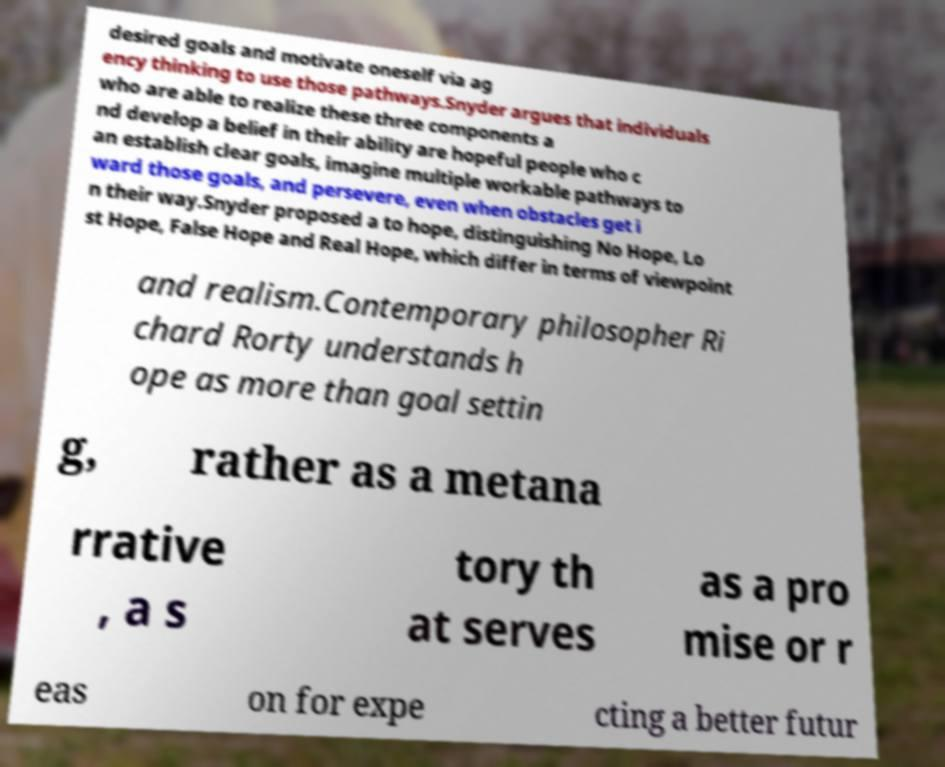Can you read and provide the text displayed in the image?This photo seems to have some interesting text. Can you extract and type it out for me? desired goals and motivate oneself via ag ency thinking to use those pathways.Snyder argues that individuals who are able to realize these three components a nd develop a belief in their ability are hopeful people who c an establish clear goals, imagine multiple workable pathways to ward those goals, and persevere, even when obstacles get i n their way.Snyder proposed a to hope, distinguishing No Hope, Lo st Hope, False Hope and Real Hope, which differ in terms of viewpoint and realism.Contemporary philosopher Ri chard Rorty understands h ope as more than goal settin g, rather as a metana rrative , a s tory th at serves as a pro mise or r eas on for expe cting a better futur 